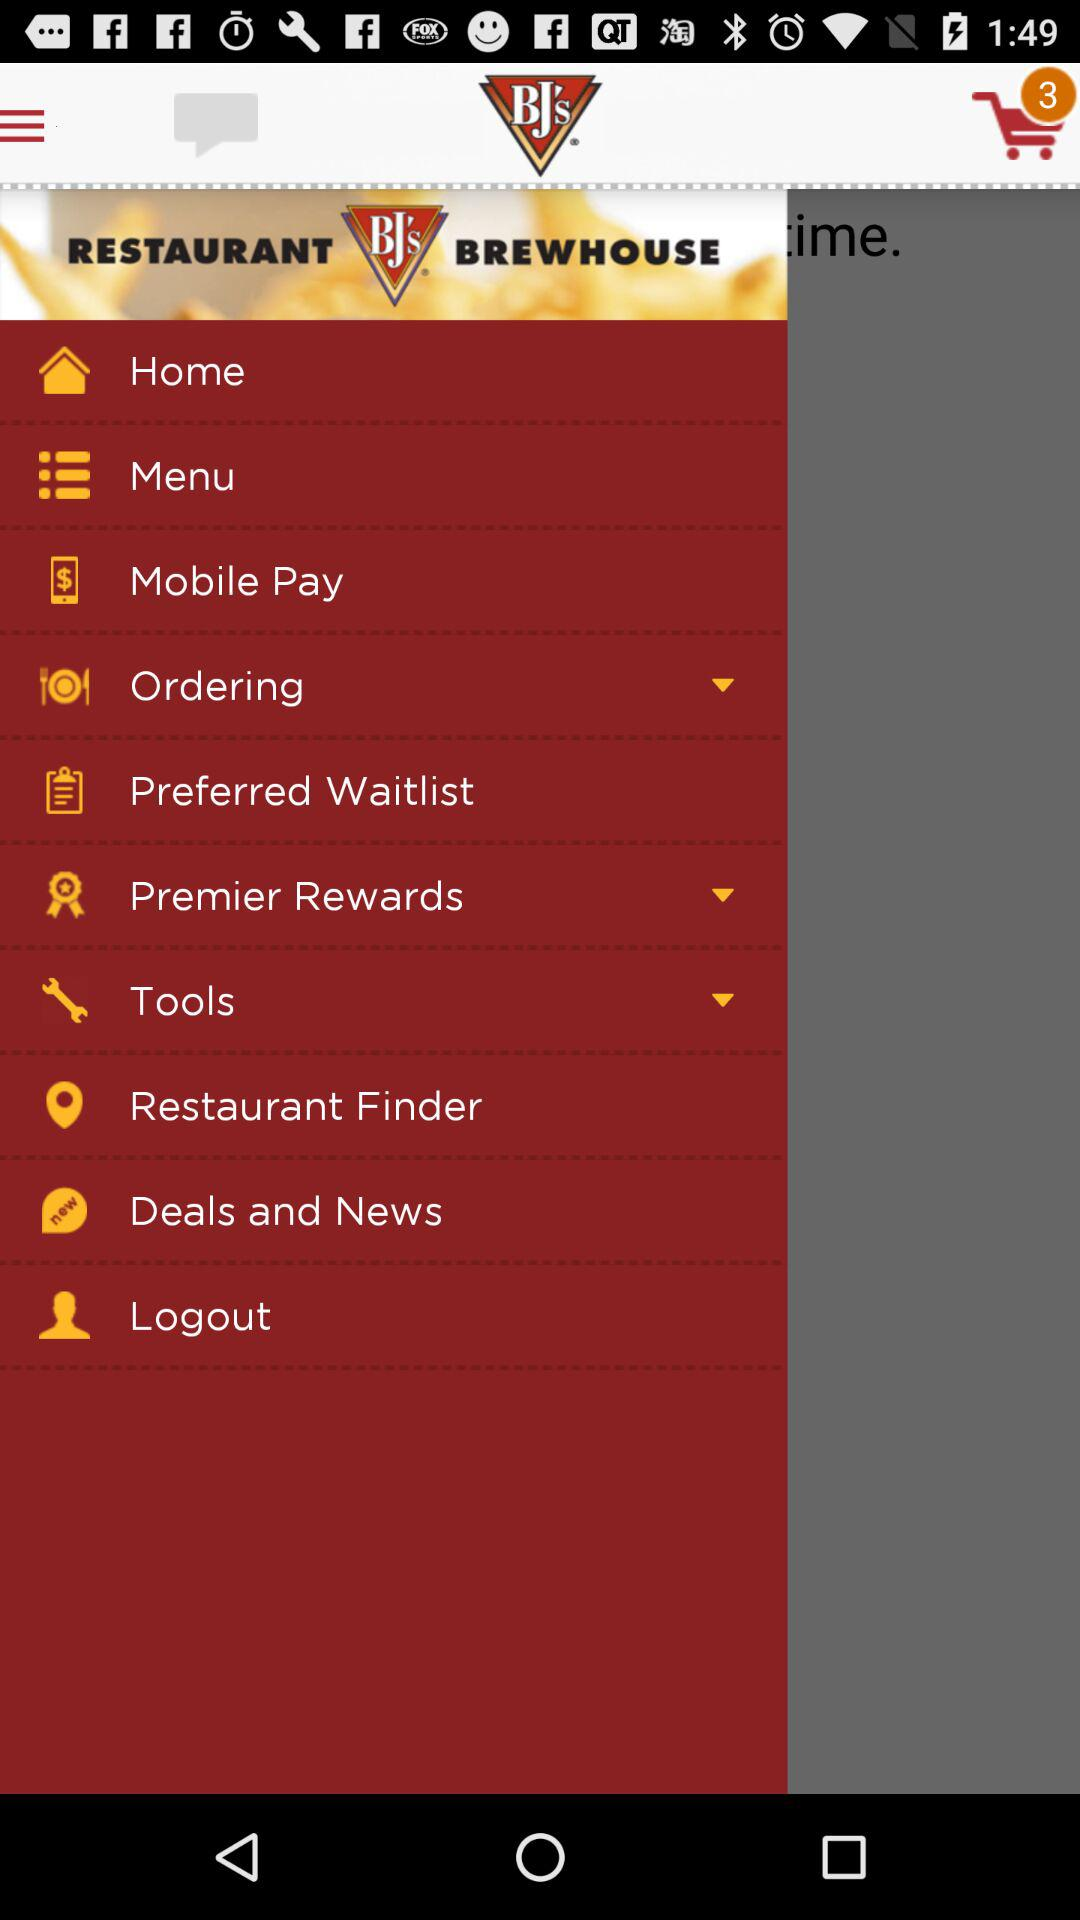How many items are in the cart? There are 3 items in the cart. 